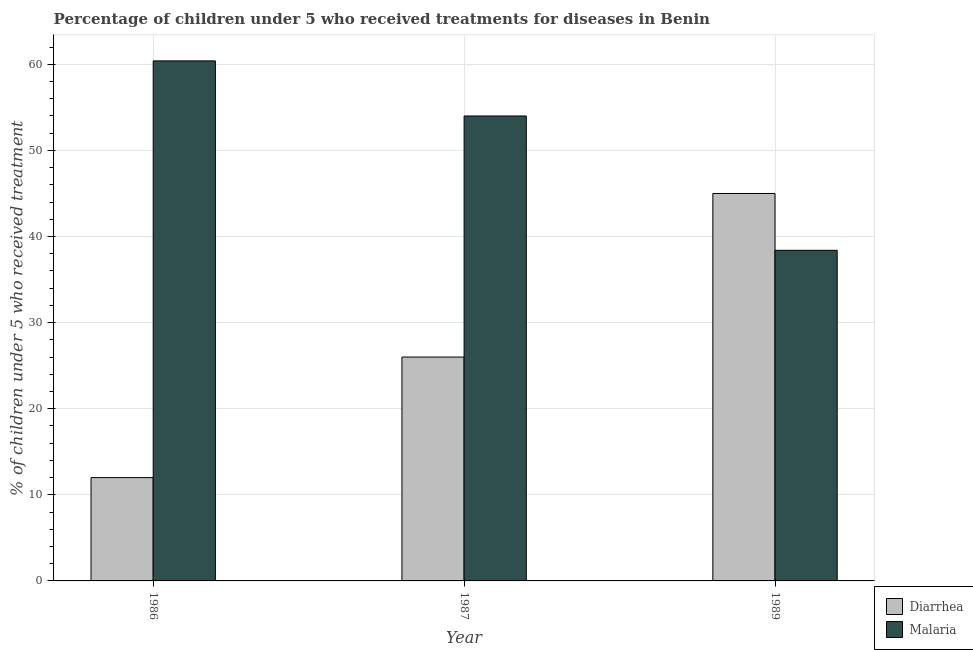Are the number of bars per tick equal to the number of legend labels?
Make the answer very short. Yes. How many bars are there on the 3rd tick from the left?
Make the answer very short. 2. How many bars are there on the 3rd tick from the right?
Your response must be concise. 2. What is the label of the 1st group of bars from the left?
Your answer should be compact. 1986. What is the percentage of children who received treatment for diarrhoea in 1986?
Provide a succinct answer. 12. Across all years, what is the maximum percentage of children who received treatment for diarrhoea?
Your response must be concise. 45. Across all years, what is the minimum percentage of children who received treatment for malaria?
Provide a short and direct response. 38.4. In which year was the percentage of children who received treatment for diarrhoea maximum?
Offer a very short reply. 1989. What is the total percentage of children who received treatment for malaria in the graph?
Your response must be concise. 152.8. What is the difference between the percentage of children who received treatment for diarrhoea in 1987 and that in 1989?
Ensure brevity in your answer.  -19. What is the average percentage of children who received treatment for malaria per year?
Ensure brevity in your answer.  50.93. In the year 1986, what is the difference between the percentage of children who received treatment for diarrhoea and percentage of children who received treatment for malaria?
Your response must be concise. 0. What is the ratio of the percentage of children who received treatment for diarrhoea in 1986 to that in 1987?
Offer a very short reply. 0.46. What is the difference between the highest and the lowest percentage of children who received treatment for diarrhoea?
Offer a terse response. 33. In how many years, is the percentage of children who received treatment for diarrhoea greater than the average percentage of children who received treatment for diarrhoea taken over all years?
Offer a terse response. 1. What does the 2nd bar from the left in 1987 represents?
Provide a succinct answer. Malaria. What does the 2nd bar from the right in 1986 represents?
Keep it short and to the point. Diarrhea. How many bars are there?
Provide a succinct answer. 6. How many years are there in the graph?
Your answer should be compact. 3. Does the graph contain any zero values?
Offer a very short reply. No. Does the graph contain grids?
Offer a terse response. Yes. What is the title of the graph?
Offer a terse response. Percentage of children under 5 who received treatments for diseases in Benin. Does "Forest" appear as one of the legend labels in the graph?
Offer a terse response. No. What is the label or title of the X-axis?
Offer a terse response. Year. What is the label or title of the Y-axis?
Your answer should be compact. % of children under 5 who received treatment. What is the % of children under 5 who received treatment in Diarrhea in 1986?
Ensure brevity in your answer.  12. What is the % of children under 5 who received treatment in Malaria in 1986?
Keep it short and to the point. 60.4. What is the % of children under 5 who received treatment of Diarrhea in 1987?
Offer a terse response. 26. What is the % of children under 5 who received treatment of Diarrhea in 1989?
Your answer should be compact. 45. What is the % of children under 5 who received treatment in Malaria in 1989?
Offer a very short reply. 38.4. Across all years, what is the maximum % of children under 5 who received treatment of Diarrhea?
Offer a terse response. 45. Across all years, what is the maximum % of children under 5 who received treatment of Malaria?
Keep it short and to the point. 60.4. Across all years, what is the minimum % of children under 5 who received treatment of Diarrhea?
Your response must be concise. 12. Across all years, what is the minimum % of children under 5 who received treatment in Malaria?
Keep it short and to the point. 38.4. What is the total % of children under 5 who received treatment in Diarrhea in the graph?
Your response must be concise. 83. What is the total % of children under 5 who received treatment in Malaria in the graph?
Your answer should be very brief. 152.8. What is the difference between the % of children under 5 who received treatment of Malaria in 1986 and that in 1987?
Your answer should be very brief. 6.4. What is the difference between the % of children under 5 who received treatment in Diarrhea in 1986 and that in 1989?
Your answer should be compact. -33. What is the difference between the % of children under 5 who received treatment of Malaria in 1987 and that in 1989?
Provide a short and direct response. 15.6. What is the difference between the % of children under 5 who received treatment of Diarrhea in 1986 and the % of children under 5 who received treatment of Malaria in 1987?
Keep it short and to the point. -42. What is the difference between the % of children under 5 who received treatment in Diarrhea in 1986 and the % of children under 5 who received treatment in Malaria in 1989?
Keep it short and to the point. -26.4. What is the average % of children under 5 who received treatment of Diarrhea per year?
Your answer should be very brief. 27.67. What is the average % of children under 5 who received treatment in Malaria per year?
Your response must be concise. 50.93. In the year 1986, what is the difference between the % of children under 5 who received treatment in Diarrhea and % of children under 5 who received treatment in Malaria?
Make the answer very short. -48.4. What is the ratio of the % of children under 5 who received treatment of Diarrhea in 1986 to that in 1987?
Give a very brief answer. 0.46. What is the ratio of the % of children under 5 who received treatment of Malaria in 1986 to that in 1987?
Offer a terse response. 1.12. What is the ratio of the % of children under 5 who received treatment of Diarrhea in 1986 to that in 1989?
Offer a very short reply. 0.27. What is the ratio of the % of children under 5 who received treatment in Malaria in 1986 to that in 1989?
Provide a succinct answer. 1.57. What is the ratio of the % of children under 5 who received treatment of Diarrhea in 1987 to that in 1989?
Offer a terse response. 0.58. What is the ratio of the % of children under 5 who received treatment in Malaria in 1987 to that in 1989?
Keep it short and to the point. 1.41. What is the difference between the highest and the second highest % of children under 5 who received treatment in Diarrhea?
Provide a short and direct response. 19. What is the difference between the highest and the lowest % of children under 5 who received treatment in Diarrhea?
Offer a terse response. 33. What is the difference between the highest and the lowest % of children under 5 who received treatment in Malaria?
Your answer should be compact. 22. 